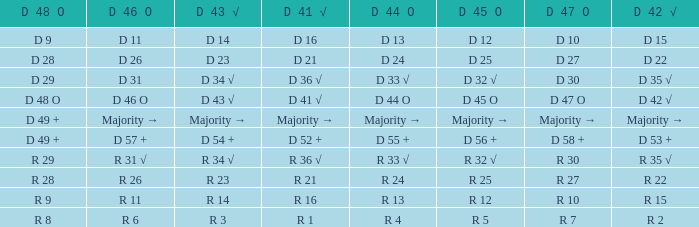Name the D 45 O with D 46 O of r 31 √ R 32 √. 